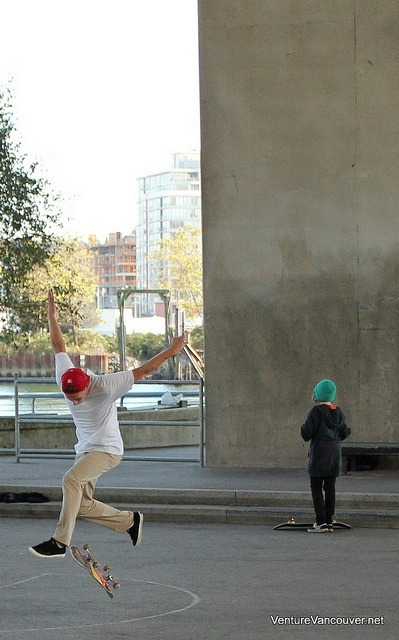Describe the objects in this image and their specific colors. I can see people in white, darkgray, and gray tones, people in white, black, gray, and teal tones, skateboard in white, gray, and darkgray tones, and skateboard in white, black, and gray tones in this image. 